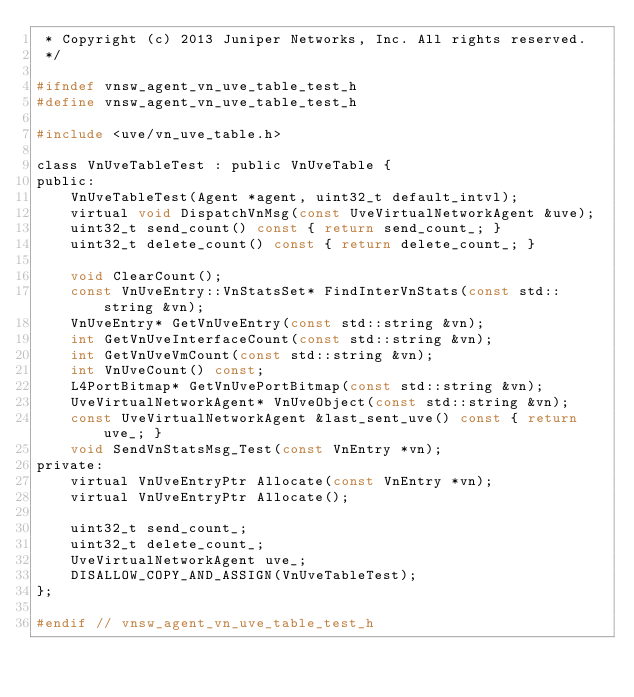<code> <loc_0><loc_0><loc_500><loc_500><_C_> * Copyright (c) 2013 Juniper Networks, Inc. All rights reserved.
 */

#ifndef vnsw_agent_vn_uve_table_test_h
#define vnsw_agent_vn_uve_table_test_h

#include <uve/vn_uve_table.h>

class VnUveTableTest : public VnUveTable {
public:
    VnUveTableTest(Agent *agent, uint32_t default_intvl);
    virtual void DispatchVnMsg(const UveVirtualNetworkAgent &uve);
    uint32_t send_count() const { return send_count_; }
    uint32_t delete_count() const { return delete_count_; }

    void ClearCount();
    const VnUveEntry::VnStatsSet* FindInterVnStats(const std::string &vn);
    VnUveEntry* GetVnUveEntry(const std::string &vn);
    int GetVnUveInterfaceCount(const std::string &vn);
    int GetVnUveVmCount(const std::string &vn);
    int VnUveCount() const;
    L4PortBitmap* GetVnUvePortBitmap(const std::string &vn);
    UveVirtualNetworkAgent* VnUveObject(const std::string &vn);
    const UveVirtualNetworkAgent &last_sent_uve() const { return uve_; }
    void SendVnStatsMsg_Test(const VnEntry *vn);
private:
    virtual VnUveEntryPtr Allocate(const VnEntry *vn);
    virtual VnUveEntryPtr Allocate();

    uint32_t send_count_;
    uint32_t delete_count_;
    UveVirtualNetworkAgent uve_;
    DISALLOW_COPY_AND_ASSIGN(VnUveTableTest);
};

#endif // vnsw_agent_vn_uve_table_test_h
</code> 